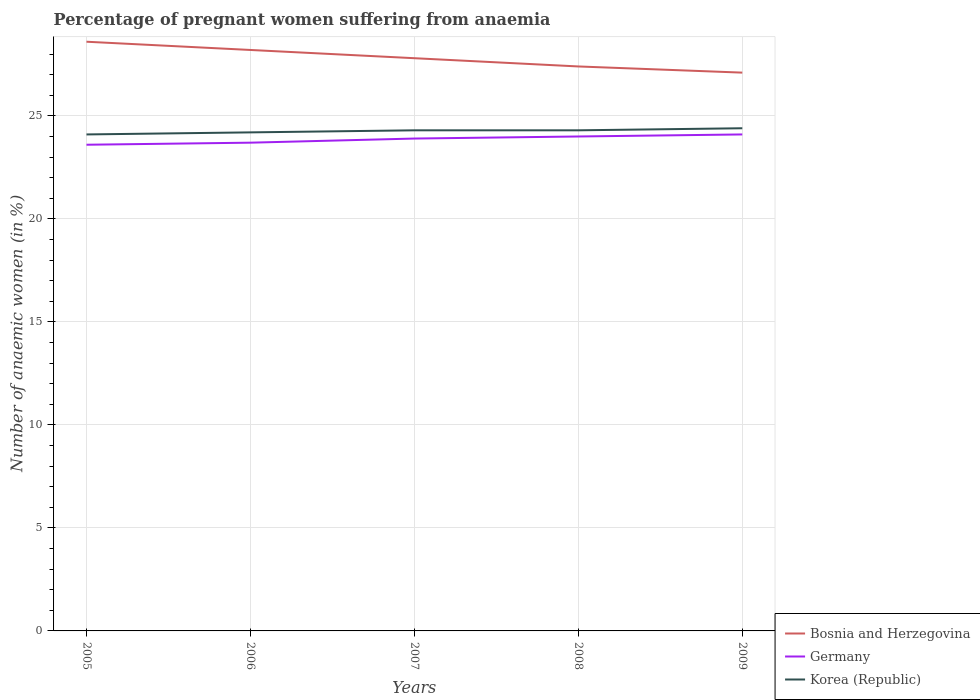Is the number of lines equal to the number of legend labels?
Ensure brevity in your answer.  Yes. Across all years, what is the maximum number of anaemic women in Germany?
Make the answer very short. 23.6. In which year was the number of anaemic women in Bosnia and Herzegovina maximum?
Your answer should be very brief. 2009. What is the total number of anaemic women in Germany in the graph?
Offer a very short reply. -0.3. What is the difference between the highest and the lowest number of anaemic women in Bosnia and Herzegovina?
Offer a very short reply. 2. How many lines are there?
Your answer should be very brief. 3. How many years are there in the graph?
Provide a succinct answer. 5. Does the graph contain grids?
Make the answer very short. Yes. Where does the legend appear in the graph?
Keep it short and to the point. Bottom right. What is the title of the graph?
Your answer should be very brief. Percentage of pregnant women suffering from anaemia. What is the label or title of the Y-axis?
Your answer should be compact. Number of anaemic women (in %). What is the Number of anaemic women (in %) in Bosnia and Herzegovina in 2005?
Give a very brief answer. 28.6. What is the Number of anaemic women (in %) of Germany in 2005?
Your answer should be compact. 23.6. What is the Number of anaemic women (in %) of Korea (Republic) in 2005?
Keep it short and to the point. 24.1. What is the Number of anaemic women (in %) in Bosnia and Herzegovina in 2006?
Keep it short and to the point. 28.2. What is the Number of anaemic women (in %) of Germany in 2006?
Your response must be concise. 23.7. What is the Number of anaemic women (in %) of Korea (Republic) in 2006?
Give a very brief answer. 24.2. What is the Number of anaemic women (in %) in Bosnia and Herzegovina in 2007?
Your response must be concise. 27.8. What is the Number of anaemic women (in %) in Germany in 2007?
Offer a terse response. 23.9. What is the Number of anaemic women (in %) in Korea (Republic) in 2007?
Your answer should be compact. 24.3. What is the Number of anaemic women (in %) of Bosnia and Herzegovina in 2008?
Your answer should be compact. 27.4. What is the Number of anaemic women (in %) of Korea (Republic) in 2008?
Your answer should be compact. 24.3. What is the Number of anaemic women (in %) in Bosnia and Herzegovina in 2009?
Ensure brevity in your answer.  27.1. What is the Number of anaemic women (in %) in Germany in 2009?
Your answer should be compact. 24.1. What is the Number of anaemic women (in %) in Korea (Republic) in 2009?
Your answer should be compact. 24.4. Across all years, what is the maximum Number of anaemic women (in %) in Bosnia and Herzegovina?
Provide a short and direct response. 28.6. Across all years, what is the maximum Number of anaemic women (in %) of Germany?
Offer a very short reply. 24.1. Across all years, what is the maximum Number of anaemic women (in %) of Korea (Republic)?
Give a very brief answer. 24.4. Across all years, what is the minimum Number of anaemic women (in %) in Bosnia and Herzegovina?
Provide a succinct answer. 27.1. Across all years, what is the minimum Number of anaemic women (in %) of Germany?
Give a very brief answer. 23.6. Across all years, what is the minimum Number of anaemic women (in %) in Korea (Republic)?
Provide a succinct answer. 24.1. What is the total Number of anaemic women (in %) of Bosnia and Herzegovina in the graph?
Your answer should be very brief. 139.1. What is the total Number of anaemic women (in %) in Germany in the graph?
Keep it short and to the point. 119.3. What is the total Number of anaemic women (in %) in Korea (Republic) in the graph?
Your answer should be compact. 121.3. What is the difference between the Number of anaemic women (in %) of Bosnia and Herzegovina in 2005 and that in 2006?
Ensure brevity in your answer.  0.4. What is the difference between the Number of anaemic women (in %) in Germany in 2005 and that in 2006?
Your answer should be very brief. -0.1. What is the difference between the Number of anaemic women (in %) of Korea (Republic) in 2005 and that in 2006?
Keep it short and to the point. -0.1. What is the difference between the Number of anaemic women (in %) in Korea (Republic) in 2005 and that in 2007?
Your answer should be compact. -0.2. What is the difference between the Number of anaemic women (in %) in Germany in 2005 and that in 2009?
Your answer should be compact. -0.5. What is the difference between the Number of anaemic women (in %) in Korea (Republic) in 2006 and that in 2007?
Your answer should be very brief. -0.1. What is the difference between the Number of anaemic women (in %) of Germany in 2006 and that in 2008?
Offer a terse response. -0.3. What is the difference between the Number of anaemic women (in %) of Germany in 2006 and that in 2009?
Provide a short and direct response. -0.4. What is the difference between the Number of anaemic women (in %) in Bosnia and Herzegovina in 2008 and that in 2009?
Provide a short and direct response. 0.3. What is the difference between the Number of anaemic women (in %) of Germany in 2008 and that in 2009?
Provide a succinct answer. -0.1. What is the difference between the Number of anaemic women (in %) of Bosnia and Herzegovina in 2005 and the Number of anaemic women (in %) of Germany in 2006?
Offer a very short reply. 4.9. What is the difference between the Number of anaemic women (in %) of Bosnia and Herzegovina in 2005 and the Number of anaemic women (in %) of Germany in 2007?
Your answer should be very brief. 4.7. What is the difference between the Number of anaemic women (in %) of Bosnia and Herzegovina in 2005 and the Number of anaemic women (in %) of Korea (Republic) in 2007?
Provide a short and direct response. 4.3. What is the difference between the Number of anaemic women (in %) of Germany in 2005 and the Number of anaemic women (in %) of Korea (Republic) in 2007?
Provide a short and direct response. -0.7. What is the difference between the Number of anaemic women (in %) in Germany in 2005 and the Number of anaemic women (in %) in Korea (Republic) in 2008?
Offer a very short reply. -0.7. What is the difference between the Number of anaemic women (in %) in Bosnia and Herzegovina in 2006 and the Number of anaemic women (in %) in Germany in 2007?
Your response must be concise. 4.3. What is the difference between the Number of anaemic women (in %) in Germany in 2006 and the Number of anaemic women (in %) in Korea (Republic) in 2007?
Give a very brief answer. -0.6. What is the difference between the Number of anaemic women (in %) in Germany in 2006 and the Number of anaemic women (in %) in Korea (Republic) in 2008?
Your answer should be very brief. -0.6. What is the difference between the Number of anaemic women (in %) of Bosnia and Herzegovina in 2006 and the Number of anaemic women (in %) of Korea (Republic) in 2009?
Provide a short and direct response. 3.8. What is the difference between the Number of anaemic women (in %) in Bosnia and Herzegovina in 2007 and the Number of anaemic women (in %) in Germany in 2008?
Provide a short and direct response. 3.8. What is the difference between the Number of anaemic women (in %) in Germany in 2007 and the Number of anaemic women (in %) in Korea (Republic) in 2008?
Give a very brief answer. -0.4. What is the difference between the Number of anaemic women (in %) in Bosnia and Herzegovina in 2007 and the Number of anaemic women (in %) in Germany in 2009?
Offer a terse response. 3.7. What is the difference between the Number of anaemic women (in %) of Bosnia and Herzegovina in 2007 and the Number of anaemic women (in %) of Korea (Republic) in 2009?
Ensure brevity in your answer.  3.4. What is the average Number of anaemic women (in %) of Bosnia and Herzegovina per year?
Your answer should be very brief. 27.82. What is the average Number of anaemic women (in %) of Germany per year?
Ensure brevity in your answer.  23.86. What is the average Number of anaemic women (in %) of Korea (Republic) per year?
Provide a short and direct response. 24.26. In the year 2005, what is the difference between the Number of anaemic women (in %) of Bosnia and Herzegovina and Number of anaemic women (in %) of Germany?
Your answer should be very brief. 5. In the year 2006, what is the difference between the Number of anaemic women (in %) in Bosnia and Herzegovina and Number of anaemic women (in %) in Germany?
Make the answer very short. 4.5. In the year 2006, what is the difference between the Number of anaemic women (in %) of Germany and Number of anaemic women (in %) of Korea (Republic)?
Your answer should be compact. -0.5. In the year 2008, what is the difference between the Number of anaemic women (in %) in Bosnia and Herzegovina and Number of anaemic women (in %) in Germany?
Give a very brief answer. 3.4. In the year 2008, what is the difference between the Number of anaemic women (in %) in Bosnia and Herzegovina and Number of anaemic women (in %) in Korea (Republic)?
Make the answer very short. 3.1. In the year 2008, what is the difference between the Number of anaemic women (in %) in Germany and Number of anaemic women (in %) in Korea (Republic)?
Offer a terse response. -0.3. In the year 2009, what is the difference between the Number of anaemic women (in %) in Bosnia and Herzegovina and Number of anaemic women (in %) in Korea (Republic)?
Ensure brevity in your answer.  2.7. What is the ratio of the Number of anaemic women (in %) of Bosnia and Herzegovina in 2005 to that in 2006?
Your answer should be compact. 1.01. What is the ratio of the Number of anaemic women (in %) in Bosnia and Herzegovina in 2005 to that in 2007?
Ensure brevity in your answer.  1.03. What is the ratio of the Number of anaemic women (in %) of Germany in 2005 to that in 2007?
Offer a very short reply. 0.99. What is the ratio of the Number of anaemic women (in %) in Korea (Republic) in 2005 to that in 2007?
Ensure brevity in your answer.  0.99. What is the ratio of the Number of anaemic women (in %) of Bosnia and Herzegovina in 2005 to that in 2008?
Your answer should be very brief. 1.04. What is the ratio of the Number of anaemic women (in %) in Germany in 2005 to that in 2008?
Keep it short and to the point. 0.98. What is the ratio of the Number of anaemic women (in %) in Korea (Republic) in 2005 to that in 2008?
Make the answer very short. 0.99. What is the ratio of the Number of anaemic women (in %) in Bosnia and Herzegovina in 2005 to that in 2009?
Keep it short and to the point. 1.06. What is the ratio of the Number of anaemic women (in %) in Germany in 2005 to that in 2009?
Your answer should be very brief. 0.98. What is the ratio of the Number of anaemic women (in %) of Bosnia and Herzegovina in 2006 to that in 2007?
Provide a succinct answer. 1.01. What is the ratio of the Number of anaemic women (in %) of Germany in 2006 to that in 2007?
Provide a short and direct response. 0.99. What is the ratio of the Number of anaemic women (in %) of Korea (Republic) in 2006 to that in 2007?
Provide a short and direct response. 1. What is the ratio of the Number of anaemic women (in %) in Bosnia and Herzegovina in 2006 to that in 2008?
Keep it short and to the point. 1.03. What is the ratio of the Number of anaemic women (in %) in Germany in 2006 to that in 2008?
Ensure brevity in your answer.  0.99. What is the ratio of the Number of anaemic women (in %) in Korea (Republic) in 2006 to that in 2008?
Provide a short and direct response. 1. What is the ratio of the Number of anaemic women (in %) in Bosnia and Herzegovina in 2006 to that in 2009?
Provide a succinct answer. 1.04. What is the ratio of the Number of anaemic women (in %) of Germany in 2006 to that in 2009?
Your response must be concise. 0.98. What is the ratio of the Number of anaemic women (in %) in Korea (Republic) in 2006 to that in 2009?
Your answer should be compact. 0.99. What is the ratio of the Number of anaemic women (in %) of Bosnia and Herzegovina in 2007 to that in 2008?
Provide a short and direct response. 1.01. What is the ratio of the Number of anaemic women (in %) of Germany in 2007 to that in 2008?
Make the answer very short. 1. What is the ratio of the Number of anaemic women (in %) of Korea (Republic) in 2007 to that in 2008?
Ensure brevity in your answer.  1. What is the ratio of the Number of anaemic women (in %) of Bosnia and Herzegovina in 2007 to that in 2009?
Keep it short and to the point. 1.03. What is the ratio of the Number of anaemic women (in %) in Korea (Republic) in 2007 to that in 2009?
Give a very brief answer. 1. What is the ratio of the Number of anaemic women (in %) of Bosnia and Herzegovina in 2008 to that in 2009?
Ensure brevity in your answer.  1.01. What is the ratio of the Number of anaemic women (in %) of Germany in 2008 to that in 2009?
Offer a very short reply. 1. What is the ratio of the Number of anaemic women (in %) in Korea (Republic) in 2008 to that in 2009?
Keep it short and to the point. 1. What is the difference between the highest and the lowest Number of anaemic women (in %) in Germany?
Provide a short and direct response. 0.5. 